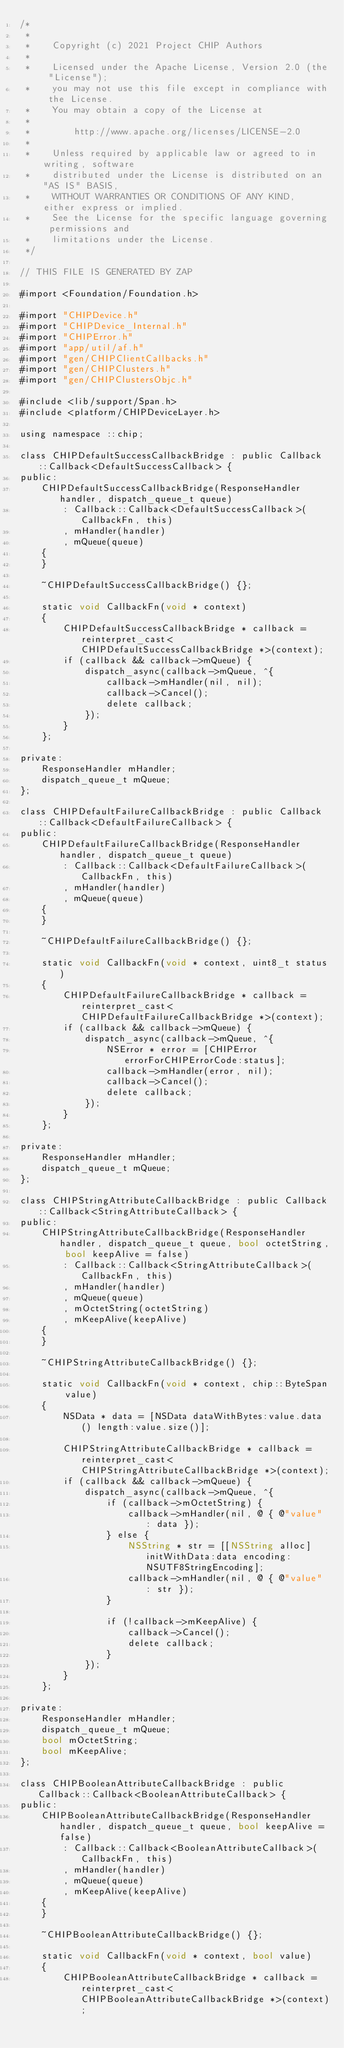Convert code to text. <code><loc_0><loc_0><loc_500><loc_500><_ObjectiveC_>/*
 *
 *    Copyright (c) 2021 Project CHIP Authors
 *
 *    Licensed under the Apache License, Version 2.0 (the "License");
 *    you may not use this file except in compliance with the License.
 *    You may obtain a copy of the License at
 *
 *        http://www.apache.org/licenses/LICENSE-2.0
 *
 *    Unless required by applicable law or agreed to in writing, software
 *    distributed under the License is distributed on an "AS IS" BASIS,
 *    WITHOUT WARRANTIES OR CONDITIONS OF ANY KIND, either express or implied.
 *    See the License for the specific language governing permissions and
 *    limitations under the License.
 */

// THIS FILE IS GENERATED BY ZAP

#import <Foundation/Foundation.h>

#import "CHIPDevice.h"
#import "CHIPDevice_Internal.h"
#import "CHIPError.h"
#import "app/util/af.h"
#import "gen/CHIPClientCallbacks.h"
#import "gen/CHIPClusters.h"
#import "gen/CHIPClustersObjc.h"

#include <lib/support/Span.h>
#include <platform/CHIPDeviceLayer.h>

using namespace ::chip;

class CHIPDefaultSuccessCallbackBridge : public Callback::Callback<DefaultSuccessCallback> {
public:
    CHIPDefaultSuccessCallbackBridge(ResponseHandler handler, dispatch_queue_t queue)
        : Callback::Callback<DefaultSuccessCallback>(CallbackFn, this)
        , mHandler(handler)
        , mQueue(queue)
    {
    }

    ~CHIPDefaultSuccessCallbackBridge() {};

    static void CallbackFn(void * context)
    {
        CHIPDefaultSuccessCallbackBridge * callback = reinterpret_cast<CHIPDefaultSuccessCallbackBridge *>(context);
        if (callback && callback->mQueue) {
            dispatch_async(callback->mQueue, ^{
                callback->mHandler(nil, nil);
                callback->Cancel();
                delete callback;
            });
        }
    };

private:
    ResponseHandler mHandler;
    dispatch_queue_t mQueue;
};

class CHIPDefaultFailureCallbackBridge : public Callback::Callback<DefaultFailureCallback> {
public:
    CHIPDefaultFailureCallbackBridge(ResponseHandler handler, dispatch_queue_t queue)
        : Callback::Callback<DefaultFailureCallback>(CallbackFn, this)
        , mHandler(handler)
        , mQueue(queue)
    {
    }

    ~CHIPDefaultFailureCallbackBridge() {};

    static void CallbackFn(void * context, uint8_t status)
    {
        CHIPDefaultFailureCallbackBridge * callback = reinterpret_cast<CHIPDefaultFailureCallbackBridge *>(context);
        if (callback && callback->mQueue) {
            dispatch_async(callback->mQueue, ^{
                NSError * error = [CHIPError errorForCHIPErrorCode:status];
                callback->mHandler(error, nil);
                callback->Cancel();
                delete callback;
            });
        }
    };

private:
    ResponseHandler mHandler;
    dispatch_queue_t mQueue;
};

class CHIPStringAttributeCallbackBridge : public Callback::Callback<StringAttributeCallback> {
public:
    CHIPStringAttributeCallbackBridge(ResponseHandler handler, dispatch_queue_t queue, bool octetString, bool keepAlive = false)
        : Callback::Callback<StringAttributeCallback>(CallbackFn, this)
        , mHandler(handler)
        , mQueue(queue)
        , mOctetString(octetString)
        , mKeepAlive(keepAlive)
    {
    }

    ~CHIPStringAttributeCallbackBridge() {};

    static void CallbackFn(void * context, chip::ByteSpan value)
    {
        NSData * data = [NSData dataWithBytes:value.data() length:value.size()];

        CHIPStringAttributeCallbackBridge * callback = reinterpret_cast<CHIPStringAttributeCallbackBridge *>(context);
        if (callback && callback->mQueue) {
            dispatch_async(callback->mQueue, ^{
                if (callback->mOctetString) {
                    callback->mHandler(nil, @ { @"value" : data });
                } else {
                    NSString * str = [[NSString alloc] initWithData:data encoding:NSUTF8StringEncoding];
                    callback->mHandler(nil, @ { @"value" : str });
                }

                if (!callback->mKeepAlive) {
                    callback->Cancel();
                    delete callback;
                }
            });
        }
    };

private:
    ResponseHandler mHandler;
    dispatch_queue_t mQueue;
    bool mOctetString;
    bool mKeepAlive;
};

class CHIPBooleanAttributeCallbackBridge : public Callback::Callback<BooleanAttributeCallback> {
public:
    CHIPBooleanAttributeCallbackBridge(ResponseHandler handler, dispatch_queue_t queue, bool keepAlive = false)
        : Callback::Callback<BooleanAttributeCallback>(CallbackFn, this)
        , mHandler(handler)
        , mQueue(queue)
        , mKeepAlive(keepAlive)
    {
    }

    ~CHIPBooleanAttributeCallbackBridge() {};

    static void CallbackFn(void * context, bool value)
    {
        CHIPBooleanAttributeCallbackBridge * callback = reinterpret_cast<CHIPBooleanAttributeCallbackBridge *>(context);</code> 